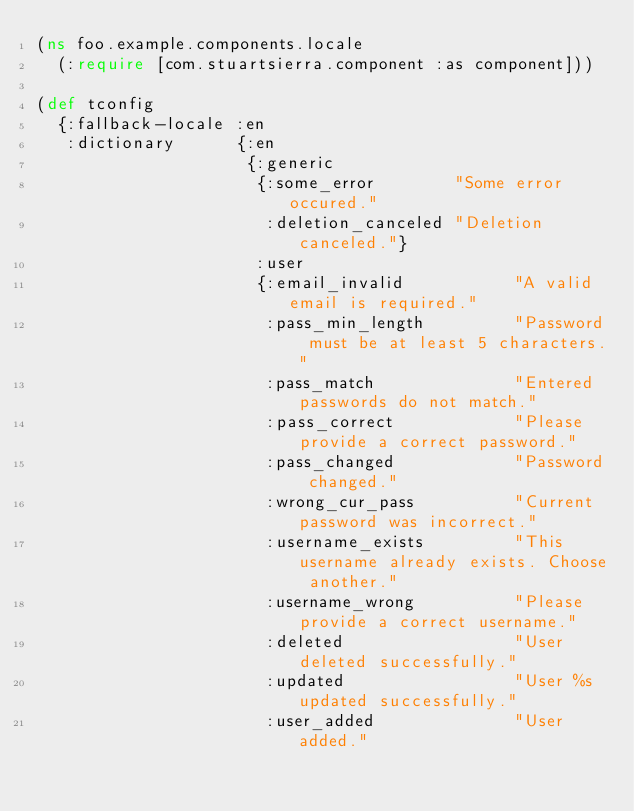<code> <loc_0><loc_0><loc_500><loc_500><_Clojure_>(ns foo.example.components.locale
  (:require [com.stuartsierra.component :as component]))

(def tconfig
  {:fallback-locale :en
   :dictionary      {:en
                     {:generic
                      {:some_error        "Some error occured."
                       :deletion_canceled "Deletion canceled."}
                      :user
                      {:email_invalid           "A valid email is required."
                       :pass_min_length         "Password must be at least 5 characters."
                       :pass_match              "Entered passwords do not match."
                       :pass_correct            "Please provide a correct password."
                       :pass_changed            "Password changed."
                       :wrong_cur_pass          "Current password was incorrect."
                       :username_exists         "This username already exists. Choose another."
                       :username_wrong          "Please provide a correct username."
                       :deleted                 "User deleted successfully."
                       :updated                 "User %s updated successfully."
                       :user_added              "User added."</code> 